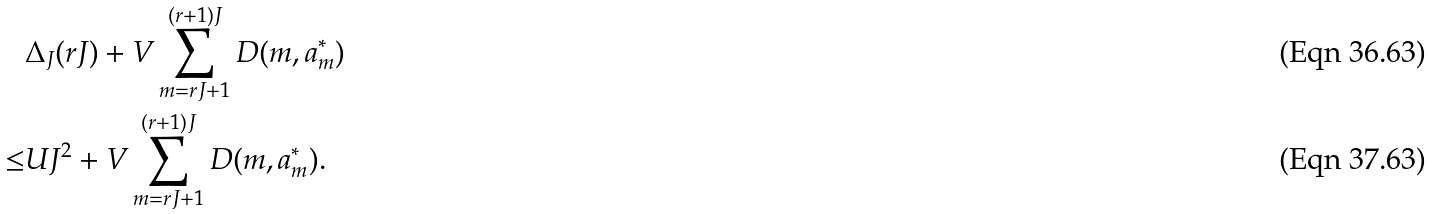Convert formula to latex. <formula><loc_0><loc_0><loc_500><loc_500>& \Delta _ { J } ( r J ) + V \sum _ { m = r J + 1 } ^ { ( r + 1 ) J } D ( m , a _ { m } ^ { * } ) \\ \leq & U J ^ { 2 } + V \sum _ { m = r J + 1 } ^ { ( r + 1 ) J } D ( m , a _ { m } ^ { * } ) .</formula> 